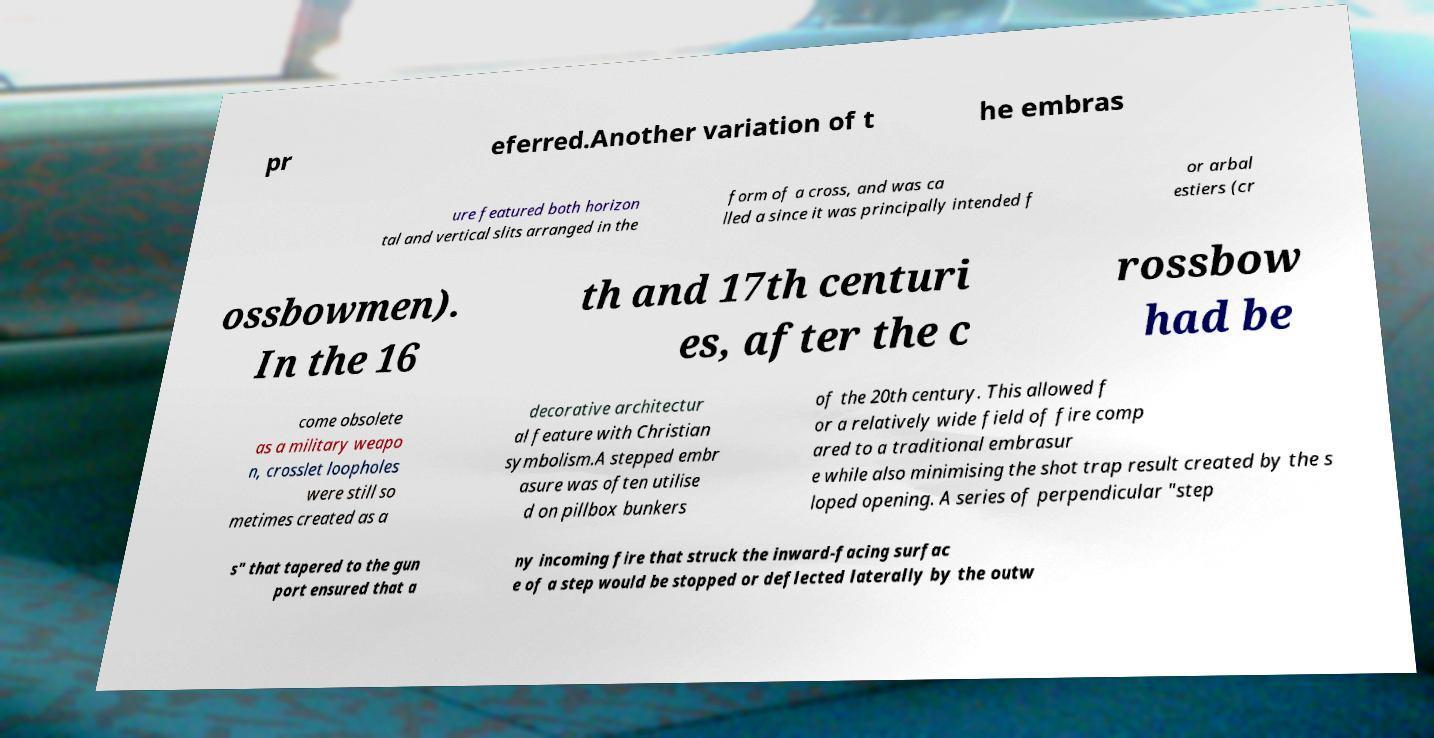Could you assist in decoding the text presented in this image and type it out clearly? pr eferred.Another variation of t he embras ure featured both horizon tal and vertical slits arranged in the form of a cross, and was ca lled a since it was principally intended f or arbal estiers (cr ossbowmen). In the 16 th and 17th centuri es, after the c rossbow had be come obsolete as a military weapo n, crosslet loopholes were still so metimes created as a decorative architectur al feature with Christian symbolism.A stepped embr asure was often utilise d on pillbox bunkers of the 20th century. This allowed f or a relatively wide field of fire comp ared to a traditional embrasur e while also minimising the shot trap result created by the s loped opening. A series of perpendicular "step s" that tapered to the gun port ensured that a ny incoming fire that struck the inward-facing surfac e of a step would be stopped or deflected laterally by the outw 